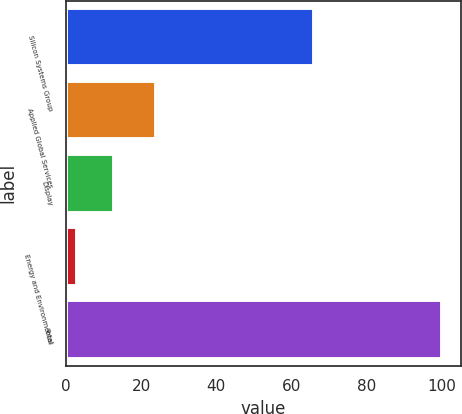Convert chart. <chart><loc_0><loc_0><loc_500><loc_500><bar_chart><fcel>Silicon Systems Group<fcel>Applied Global Services<fcel>Display<fcel>Energy and Environmental<fcel>Total<nl><fcel>66<fcel>24<fcel>12.7<fcel>3<fcel>100<nl></chart> 